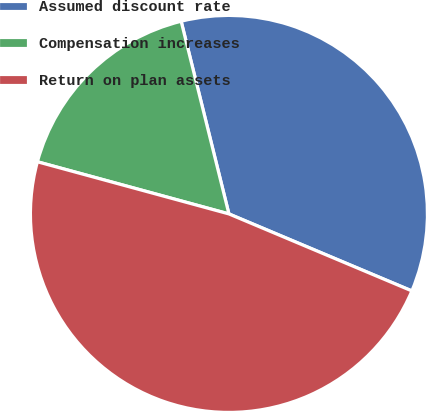Convert chart. <chart><loc_0><loc_0><loc_500><loc_500><pie_chart><fcel>Assumed discount rate<fcel>Compensation increases<fcel>Return on plan assets<nl><fcel>35.21%<fcel>16.9%<fcel>47.89%<nl></chart> 